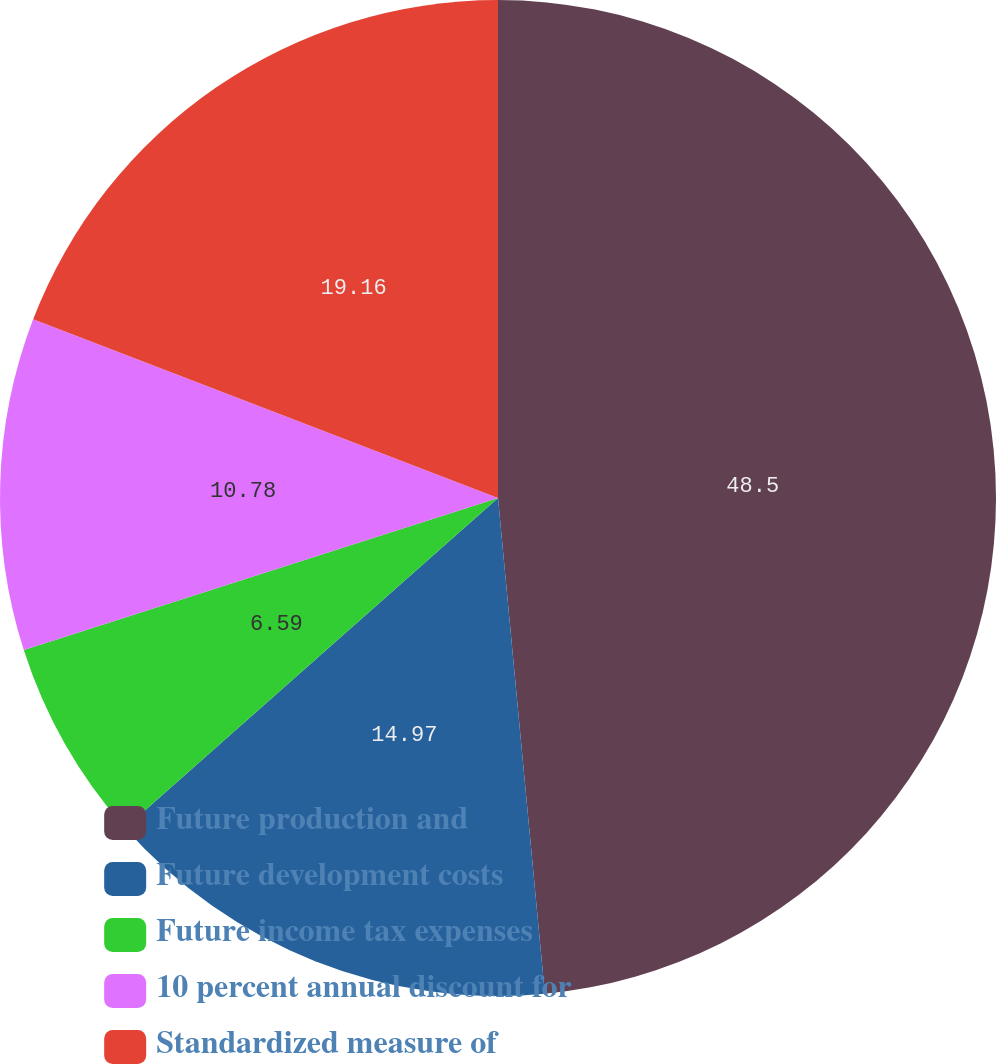Convert chart. <chart><loc_0><loc_0><loc_500><loc_500><pie_chart><fcel>Future production and<fcel>Future development costs<fcel>Future income tax expenses<fcel>10 percent annual discount for<fcel>Standardized measure of<nl><fcel>48.5%<fcel>14.97%<fcel>6.59%<fcel>10.78%<fcel>19.16%<nl></chart> 